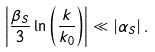<formula> <loc_0><loc_0><loc_500><loc_500>\left | \frac { \beta _ { S } } { 3 } \ln \left ( \frac { k } { k _ { 0 } } \right ) \right | \ll \left | \alpha _ { S } \right | .</formula> 